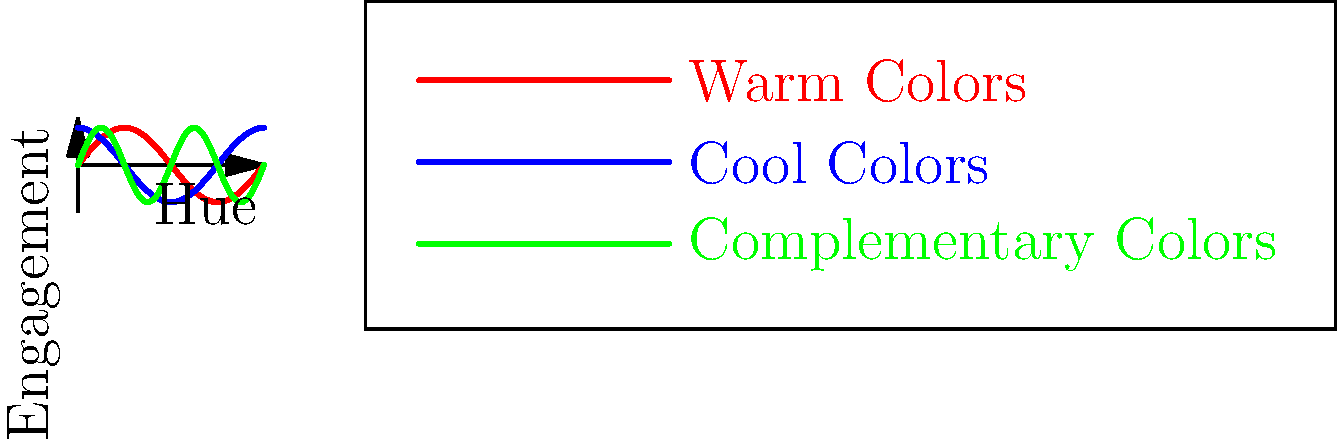As an independent studio head focusing on edgy, niche content for digital platforms, you're analyzing the impact of color theory on viewer engagement. The graph shows three color schemes: warm colors (red line), cool colors (blue line), and complementary colors (green line). Based on the engagement patterns depicted, which color scheme would you recommend for a high-energy, avant-garde digital series aimed at maximizing viewer engagement throughout its runtime? To answer this question, we need to analyze the engagement patterns for each color scheme:

1. Warm Colors (Red Line):
   - Shows a gradual increase in engagement from 0 to π/2
   - Peaks at maximum engagement (0.8) at π/2
   - Gradually decreases back to 0 at 2π

2. Cool Colors (Blue Line):
   - Starts at maximum engagement (0.8)
   - Gradually decreases to 0 at π/2
   - Increases back to maximum engagement at 2π

3. Complementary Colors (Green Line):
   - Oscillates more frequently between high and low engagement
   - Completes two full cycles within the given range
   - Peaks at 0.8 and troughs at -0.8

For a high-energy, avant-garde digital series, we want to maintain high viewer engagement throughout the runtime. The complementary color scheme (green line) offers:

1. More frequent peaks in engagement
2. The highest overall average engagement
3. Dynamic shifts that align with the edgy, high-energy content

While warm and cool colors have their merits, they show longer periods of lower engagement. The complementary color scheme keeps the audience more consistently engaged, which is crucial for niche, edgy content on digital platforms where viewer retention is key.
Answer: Complementary color scheme 